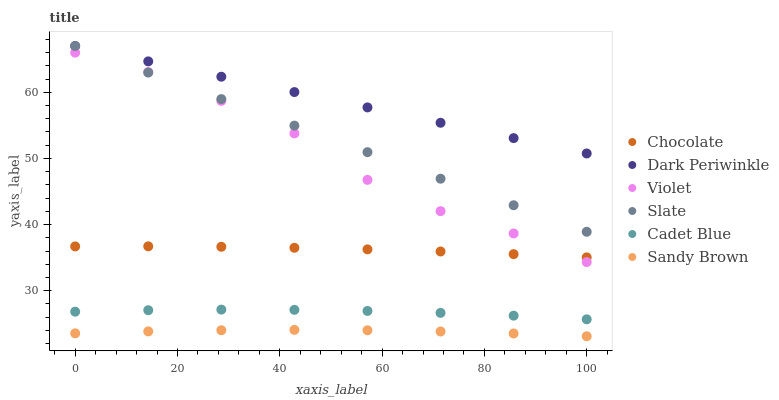Does Sandy Brown have the minimum area under the curve?
Answer yes or no. Yes. Does Dark Periwinkle have the maximum area under the curve?
Answer yes or no. Yes. Does Slate have the minimum area under the curve?
Answer yes or no. No. Does Slate have the maximum area under the curve?
Answer yes or no. No. Is Dark Periwinkle the smoothest?
Answer yes or no. Yes. Is Violet the roughest?
Answer yes or no. Yes. Is Slate the smoothest?
Answer yes or no. No. Is Slate the roughest?
Answer yes or no. No. Does Sandy Brown have the lowest value?
Answer yes or no. Yes. Does Slate have the lowest value?
Answer yes or no. No. Does Dark Periwinkle have the highest value?
Answer yes or no. Yes. Does Chocolate have the highest value?
Answer yes or no. No. Is Sandy Brown less than Cadet Blue?
Answer yes or no. Yes. Is Dark Periwinkle greater than Cadet Blue?
Answer yes or no. Yes. Does Slate intersect Violet?
Answer yes or no. Yes. Is Slate less than Violet?
Answer yes or no. No. Is Slate greater than Violet?
Answer yes or no. No. Does Sandy Brown intersect Cadet Blue?
Answer yes or no. No. 